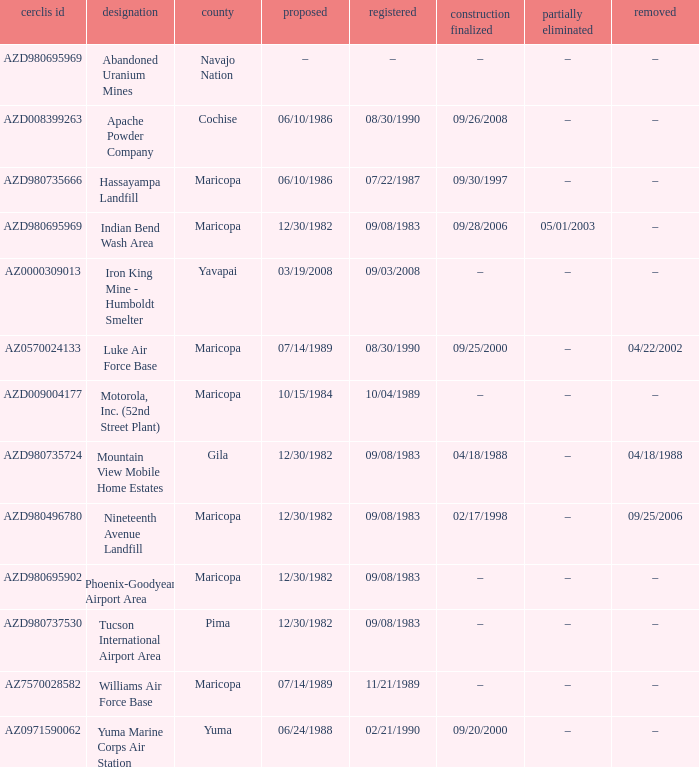When was the site listed when the county is cochise? 08/30/1990. 